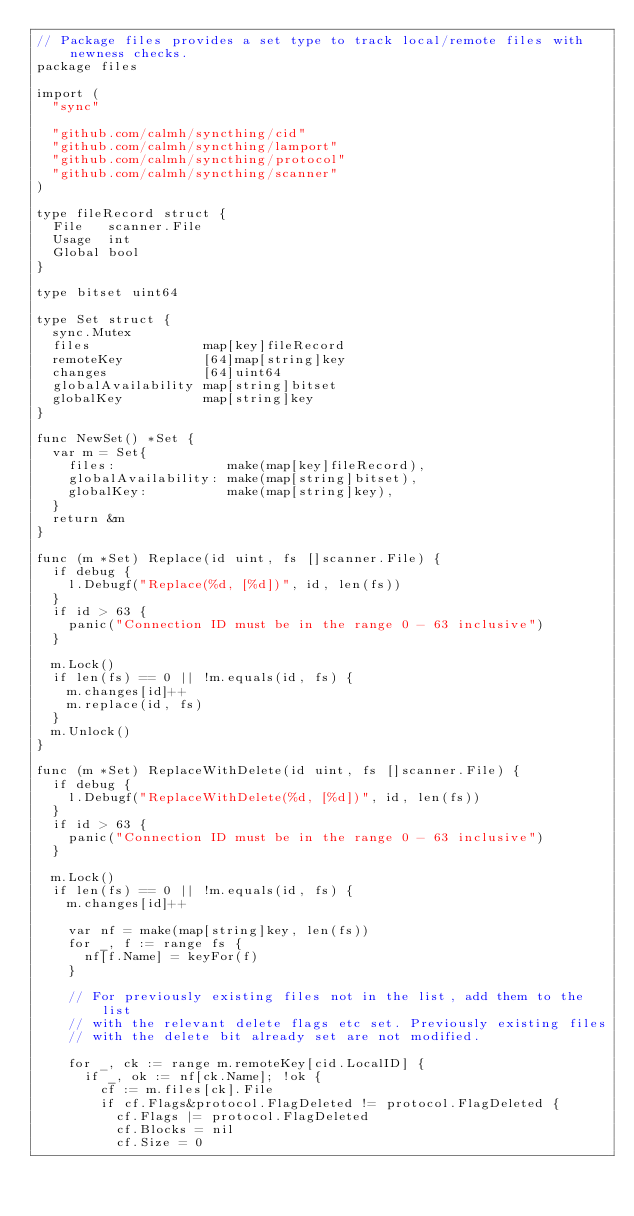<code> <loc_0><loc_0><loc_500><loc_500><_Go_>// Package files provides a set type to track local/remote files with newness checks.
package files

import (
	"sync"

	"github.com/calmh/syncthing/cid"
	"github.com/calmh/syncthing/lamport"
	"github.com/calmh/syncthing/protocol"
	"github.com/calmh/syncthing/scanner"
)

type fileRecord struct {
	File   scanner.File
	Usage  int
	Global bool
}

type bitset uint64

type Set struct {
	sync.Mutex
	files              map[key]fileRecord
	remoteKey          [64]map[string]key
	changes            [64]uint64
	globalAvailability map[string]bitset
	globalKey          map[string]key
}

func NewSet() *Set {
	var m = Set{
		files:              make(map[key]fileRecord),
		globalAvailability: make(map[string]bitset),
		globalKey:          make(map[string]key),
	}
	return &m
}

func (m *Set) Replace(id uint, fs []scanner.File) {
	if debug {
		l.Debugf("Replace(%d, [%d])", id, len(fs))
	}
	if id > 63 {
		panic("Connection ID must be in the range 0 - 63 inclusive")
	}

	m.Lock()
	if len(fs) == 0 || !m.equals(id, fs) {
		m.changes[id]++
		m.replace(id, fs)
	}
	m.Unlock()
}

func (m *Set) ReplaceWithDelete(id uint, fs []scanner.File) {
	if debug {
		l.Debugf("ReplaceWithDelete(%d, [%d])", id, len(fs))
	}
	if id > 63 {
		panic("Connection ID must be in the range 0 - 63 inclusive")
	}

	m.Lock()
	if len(fs) == 0 || !m.equals(id, fs) {
		m.changes[id]++

		var nf = make(map[string]key, len(fs))
		for _, f := range fs {
			nf[f.Name] = keyFor(f)
		}

		// For previously existing files not in the list, add them to the list
		// with the relevant delete flags etc set. Previously existing files
		// with the delete bit already set are not modified.

		for _, ck := range m.remoteKey[cid.LocalID] {
			if _, ok := nf[ck.Name]; !ok {
				cf := m.files[ck].File
				if cf.Flags&protocol.FlagDeleted != protocol.FlagDeleted {
					cf.Flags |= protocol.FlagDeleted
					cf.Blocks = nil
					cf.Size = 0</code> 